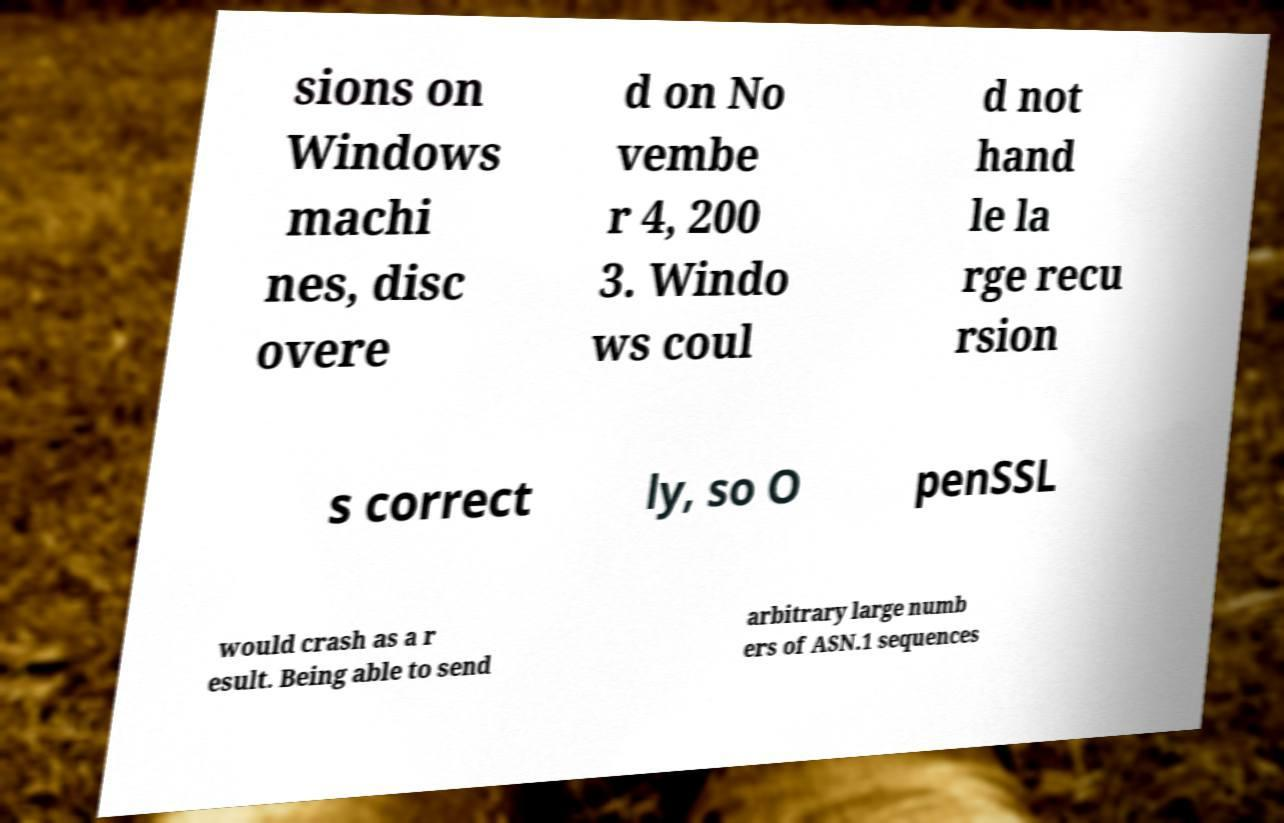Can you read and provide the text displayed in the image?This photo seems to have some interesting text. Can you extract and type it out for me? sions on Windows machi nes, disc overe d on No vembe r 4, 200 3. Windo ws coul d not hand le la rge recu rsion s correct ly, so O penSSL would crash as a r esult. Being able to send arbitrary large numb ers of ASN.1 sequences 